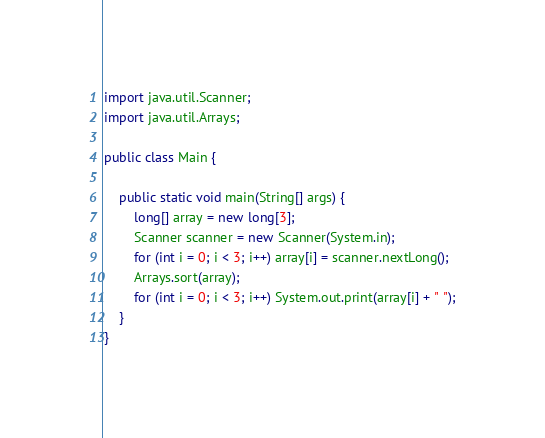<code> <loc_0><loc_0><loc_500><loc_500><_Java_>import java.util.Scanner;
import java.util.Arrays;

public class Main {

    public static void main(String[] args) {
        long[] array = new long[3];
        Scanner scanner = new Scanner(System.in);
        for (int i = 0; i < 3; i++) array[i] = scanner.nextLong();
        Arrays.sort(array);
        for (int i = 0; i < 3; i++) System.out.print(array[i] + " ");
    }
}</code> 